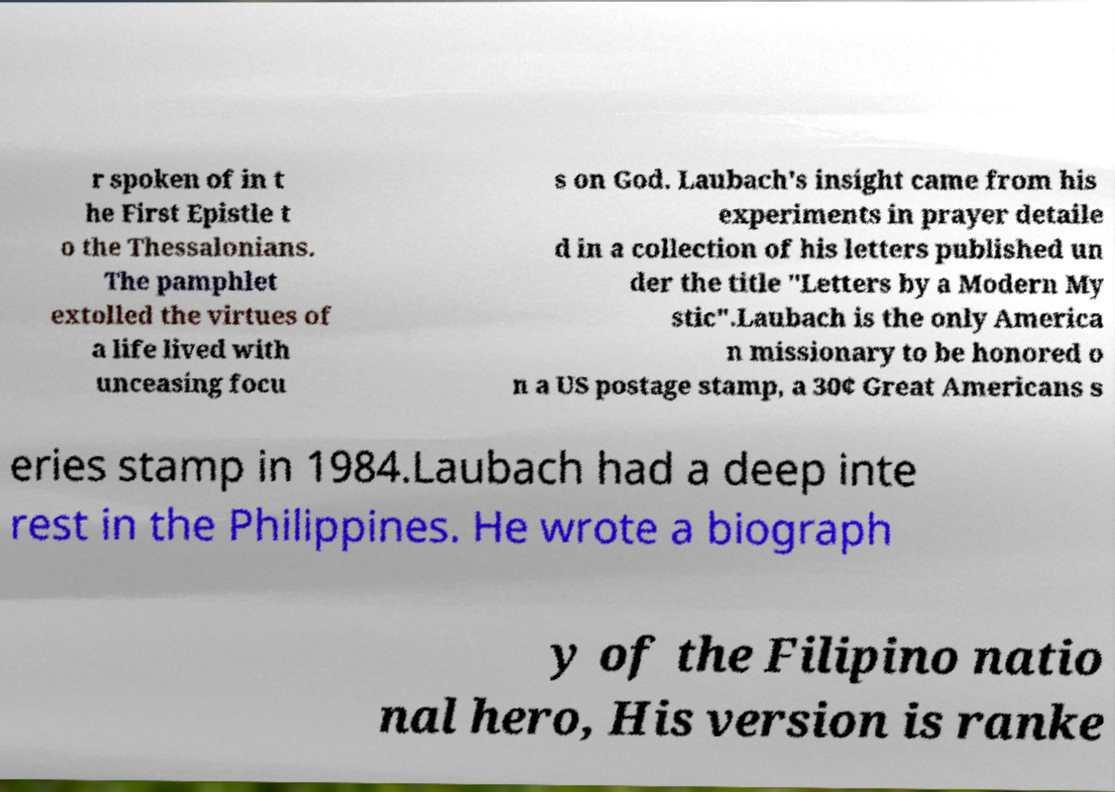Can you read and provide the text displayed in the image?This photo seems to have some interesting text. Can you extract and type it out for me? r spoken of in t he First Epistle t o the Thessalonians. The pamphlet extolled the virtues of a life lived with unceasing focu s on God. Laubach's insight came from his experiments in prayer detaile d in a collection of his letters published un der the title "Letters by a Modern My stic".Laubach is the only America n missionary to be honored o n a US postage stamp, a 30¢ Great Americans s eries stamp in 1984.Laubach had a deep inte rest in the Philippines. He wrote a biograph y of the Filipino natio nal hero, His version is ranke 